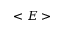Convert formula to latex. <formula><loc_0><loc_0><loc_500><loc_500>< E ></formula> 